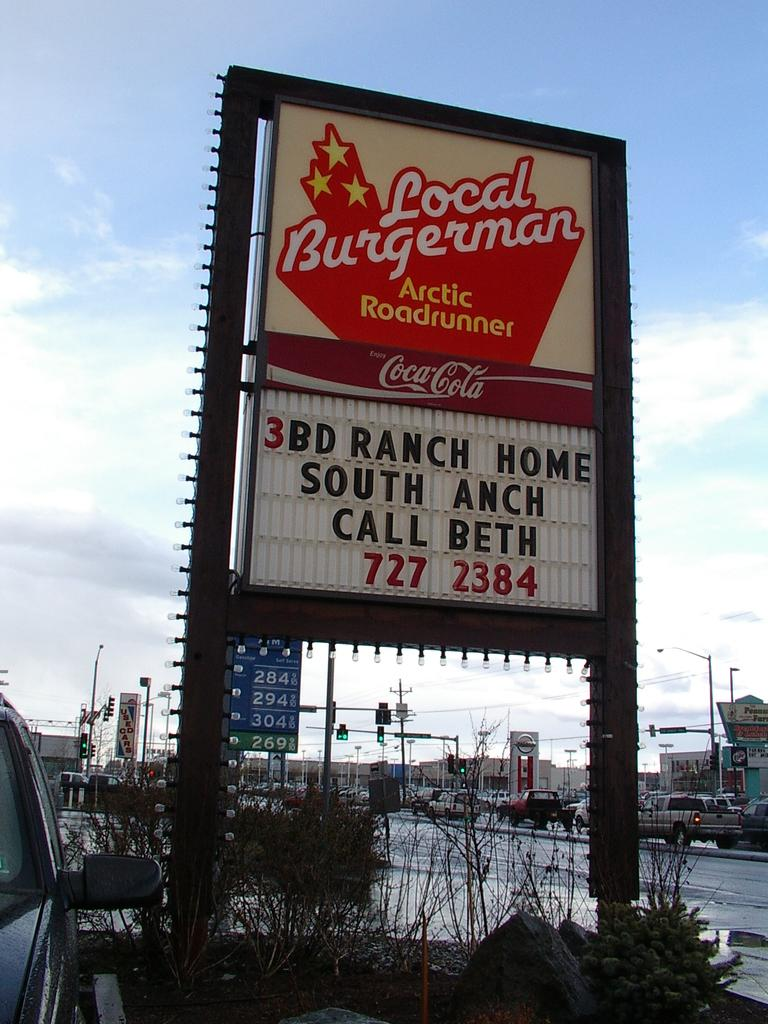What is located in the middle of the image? There is a boat in the middle of the image. What can be seen on the right side of the image? There is a road on the right side of the image. What is visible at the top of the image? The sky is visible at the top of the image. What type of destruction can be seen happening to the boat in the image? There is no destruction happening to the boat in the image; it appears to be stationary. How does the behavior of the boat in the image compare to that of a typical boat? The image does not show the boat in motion, so it is not possible to compare its behavior to that of a typical boat. 